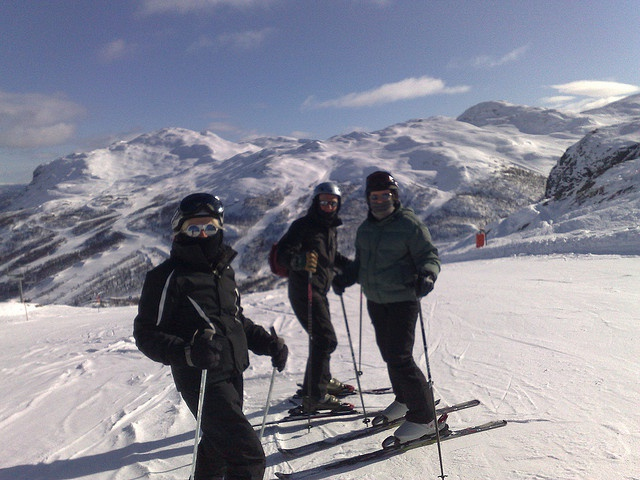Describe the objects in this image and their specific colors. I can see people in gray, black, and darkgray tones, people in gray and black tones, people in gray and black tones, skis in gray, black, lightgray, and darkgray tones, and backpack in gray, black, and darkgray tones in this image. 